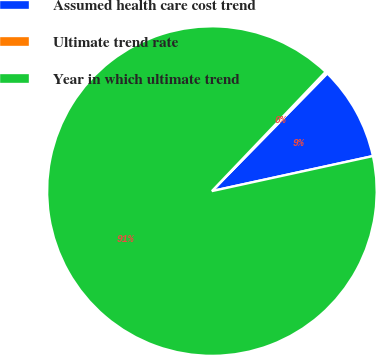Convert chart to OTSL. <chart><loc_0><loc_0><loc_500><loc_500><pie_chart><fcel>Assumed health care cost trend<fcel>Ultimate trend rate<fcel>Year in which ultimate trend<nl><fcel>9.25%<fcel>0.22%<fcel>90.52%<nl></chart> 